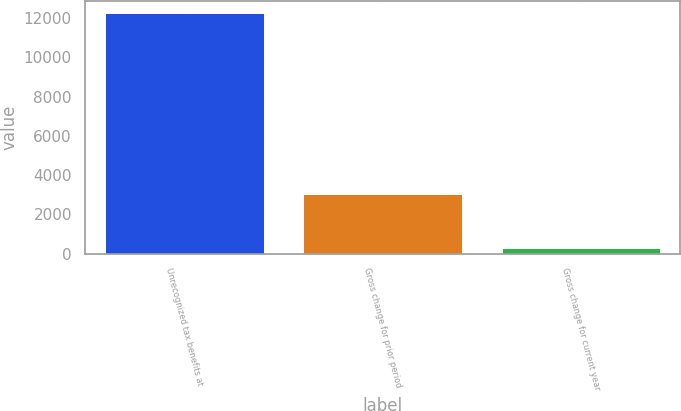Convert chart. <chart><loc_0><loc_0><loc_500><loc_500><bar_chart><fcel>Unrecognized tax benefits at<fcel>Gross change for prior period<fcel>Gross change for current year<nl><fcel>12264<fcel>3029<fcel>268<nl></chart> 